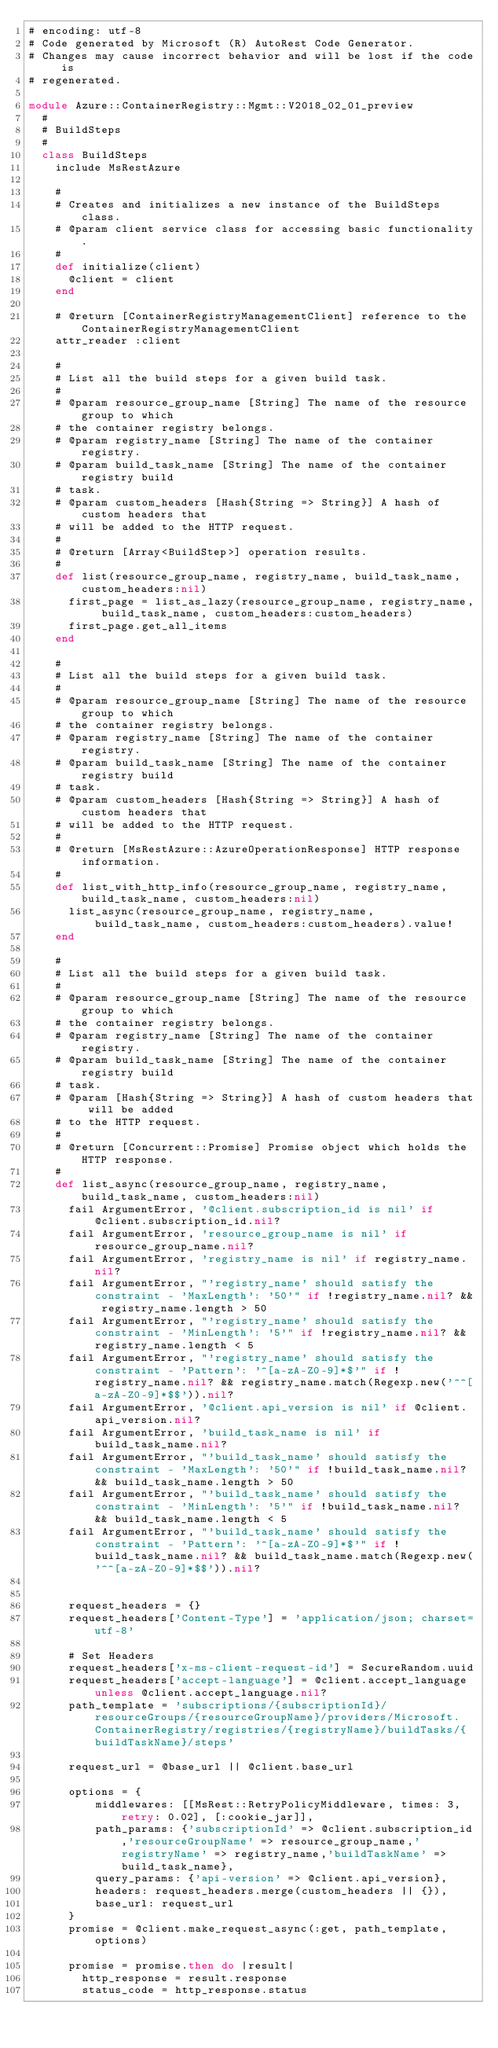Convert code to text. <code><loc_0><loc_0><loc_500><loc_500><_Ruby_># encoding: utf-8
# Code generated by Microsoft (R) AutoRest Code Generator.
# Changes may cause incorrect behavior and will be lost if the code is
# regenerated.

module Azure::ContainerRegistry::Mgmt::V2018_02_01_preview
  #
  # BuildSteps
  #
  class BuildSteps
    include MsRestAzure

    #
    # Creates and initializes a new instance of the BuildSteps class.
    # @param client service class for accessing basic functionality.
    #
    def initialize(client)
      @client = client
    end

    # @return [ContainerRegistryManagementClient] reference to the ContainerRegistryManagementClient
    attr_reader :client

    #
    # List all the build steps for a given build task.
    #
    # @param resource_group_name [String] The name of the resource group to which
    # the container registry belongs.
    # @param registry_name [String] The name of the container registry.
    # @param build_task_name [String] The name of the container registry build
    # task.
    # @param custom_headers [Hash{String => String}] A hash of custom headers that
    # will be added to the HTTP request.
    #
    # @return [Array<BuildStep>] operation results.
    #
    def list(resource_group_name, registry_name, build_task_name, custom_headers:nil)
      first_page = list_as_lazy(resource_group_name, registry_name, build_task_name, custom_headers:custom_headers)
      first_page.get_all_items
    end

    #
    # List all the build steps for a given build task.
    #
    # @param resource_group_name [String] The name of the resource group to which
    # the container registry belongs.
    # @param registry_name [String] The name of the container registry.
    # @param build_task_name [String] The name of the container registry build
    # task.
    # @param custom_headers [Hash{String => String}] A hash of custom headers that
    # will be added to the HTTP request.
    #
    # @return [MsRestAzure::AzureOperationResponse] HTTP response information.
    #
    def list_with_http_info(resource_group_name, registry_name, build_task_name, custom_headers:nil)
      list_async(resource_group_name, registry_name, build_task_name, custom_headers:custom_headers).value!
    end

    #
    # List all the build steps for a given build task.
    #
    # @param resource_group_name [String] The name of the resource group to which
    # the container registry belongs.
    # @param registry_name [String] The name of the container registry.
    # @param build_task_name [String] The name of the container registry build
    # task.
    # @param [Hash{String => String}] A hash of custom headers that will be added
    # to the HTTP request.
    #
    # @return [Concurrent::Promise] Promise object which holds the HTTP response.
    #
    def list_async(resource_group_name, registry_name, build_task_name, custom_headers:nil)
      fail ArgumentError, '@client.subscription_id is nil' if @client.subscription_id.nil?
      fail ArgumentError, 'resource_group_name is nil' if resource_group_name.nil?
      fail ArgumentError, 'registry_name is nil' if registry_name.nil?
      fail ArgumentError, "'registry_name' should satisfy the constraint - 'MaxLength': '50'" if !registry_name.nil? && registry_name.length > 50
      fail ArgumentError, "'registry_name' should satisfy the constraint - 'MinLength': '5'" if !registry_name.nil? && registry_name.length < 5
      fail ArgumentError, "'registry_name' should satisfy the constraint - 'Pattern': '^[a-zA-Z0-9]*$'" if !registry_name.nil? && registry_name.match(Regexp.new('^^[a-zA-Z0-9]*$$')).nil?
      fail ArgumentError, '@client.api_version is nil' if @client.api_version.nil?
      fail ArgumentError, 'build_task_name is nil' if build_task_name.nil?
      fail ArgumentError, "'build_task_name' should satisfy the constraint - 'MaxLength': '50'" if !build_task_name.nil? && build_task_name.length > 50
      fail ArgumentError, "'build_task_name' should satisfy the constraint - 'MinLength': '5'" if !build_task_name.nil? && build_task_name.length < 5
      fail ArgumentError, "'build_task_name' should satisfy the constraint - 'Pattern': '^[a-zA-Z0-9]*$'" if !build_task_name.nil? && build_task_name.match(Regexp.new('^^[a-zA-Z0-9]*$$')).nil?


      request_headers = {}
      request_headers['Content-Type'] = 'application/json; charset=utf-8'

      # Set Headers
      request_headers['x-ms-client-request-id'] = SecureRandom.uuid
      request_headers['accept-language'] = @client.accept_language unless @client.accept_language.nil?
      path_template = 'subscriptions/{subscriptionId}/resourceGroups/{resourceGroupName}/providers/Microsoft.ContainerRegistry/registries/{registryName}/buildTasks/{buildTaskName}/steps'

      request_url = @base_url || @client.base_url

      options = {
          middlewares: [[MsRest::RetryPolicyMiddleware, times: 3, retry: 0.02], [:cookie_jar]],
          path_params: {'subscriptionId' => @client.subscription_id,'resourceGroupName' => resource_group_name,'registryName' => registry_name,'buildTaskName' => build_task_name},
          query_params: {'api-version' => @client.api_version},
          headers: request_headers.merge(custom_headers || {}),
          base_url: request_url
      }
      promise = @client.make_request_async(:get, path_template, options)

      promise = promise.then do |result|
        http_response = result.response
        status_code = http_response.status</code> 